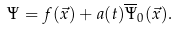<formula> <loc_0><loc_0><loc_500><loc_500>\Psi = f ( \vec { x } ) + a ( t ) \overline { \Psi } _ { 0 } ( \vec { x } ) .</formula> 